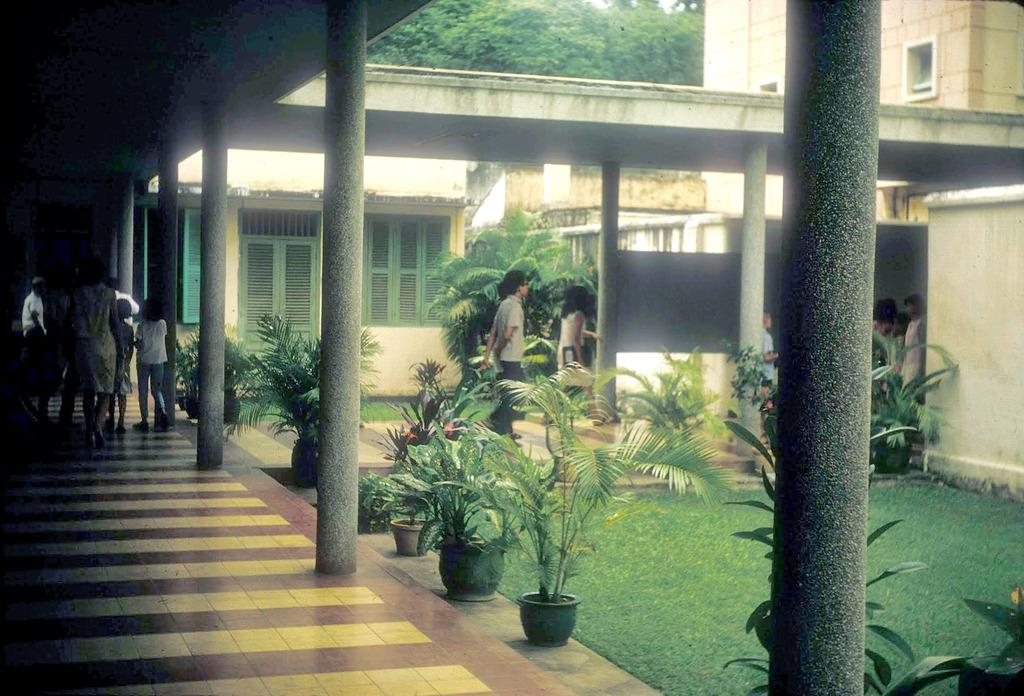What types of living organisms can be seen in the image? Plants and persons are visible in the image. What architectural features are present in the image? Pillars and buildings are present in the image. What can be seen at the top of the image? Trees are present at the top of the image. What scent can be detected from the plants in the image? There is no information about the scent of the plants in the image, as smell is not a sense that can be captured in a photograph. What season is depicted in the image? The image does not provide any information about the season, as it only shows plants, persons, pillars, buildings, and trees, which can be present in any season. 